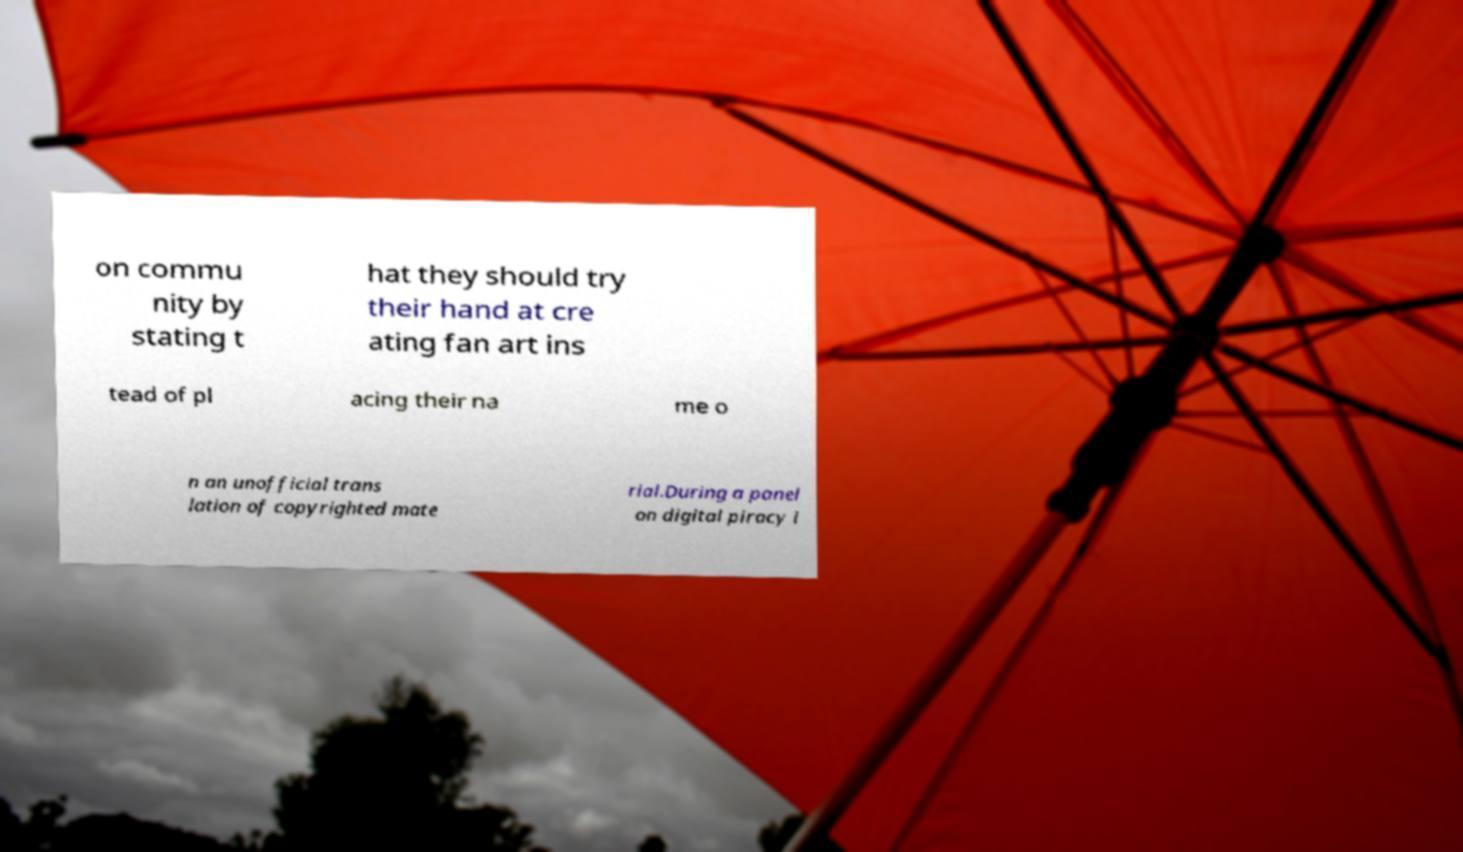For documentation purposes, I need the text within this image transcribed. Could you provide that? on commu nity by stating t hat they should try their hand at cre ating fan art ins tead of pl acing their na me o n an unofficial trans lation of copyrighted mate rial.During a panel on digital piracy i 